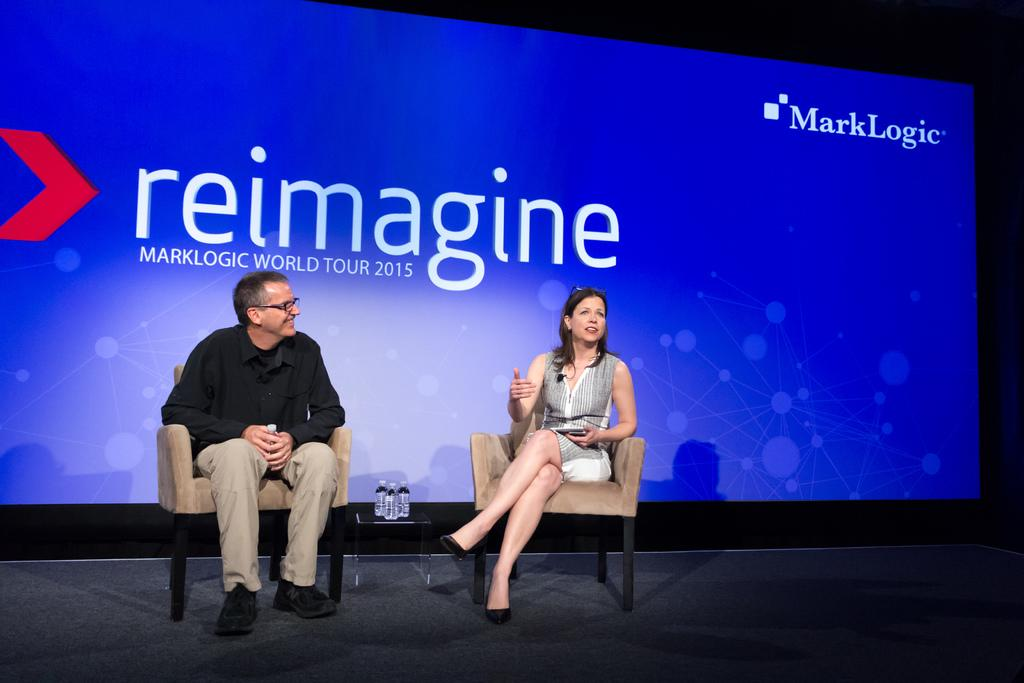What are the persons in the image doing? The persons in the image are sitting on chairs in the center of the image. Where are the chairs located? The chairs are on a dais. What can be seen in the background of the image? There is a screen in the background of the image. What type of tail can be seen on the persons sitting on chairs in the image? There are no tails visible on the persons sitting on chairs in the image. What journey are the persons in the image embarking on? The image does not provide any information about a journey that the persons might be embarking on. 